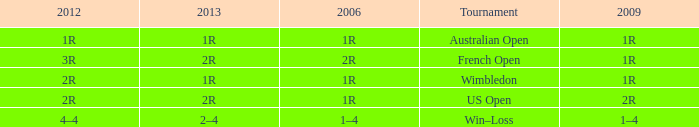What is the 2006 when the 2013 is 1r, and the 2012 is 1r? 1R. 